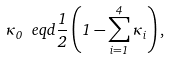Convert formula to latex. <formula><loc_0><loc_0><loc_500><loc_500>\kappa _ { 0 } \ e q d \frac { 1 } { 2 } \left ( 1 - \sum _ { i = 1 } ^ { 4 } \kappa _ { i } \right ) ,</formula> 